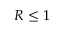Convert formula to latex. <formula><loc_0><loc_0><loc_500><loc_500>R \leq 1</formula> 